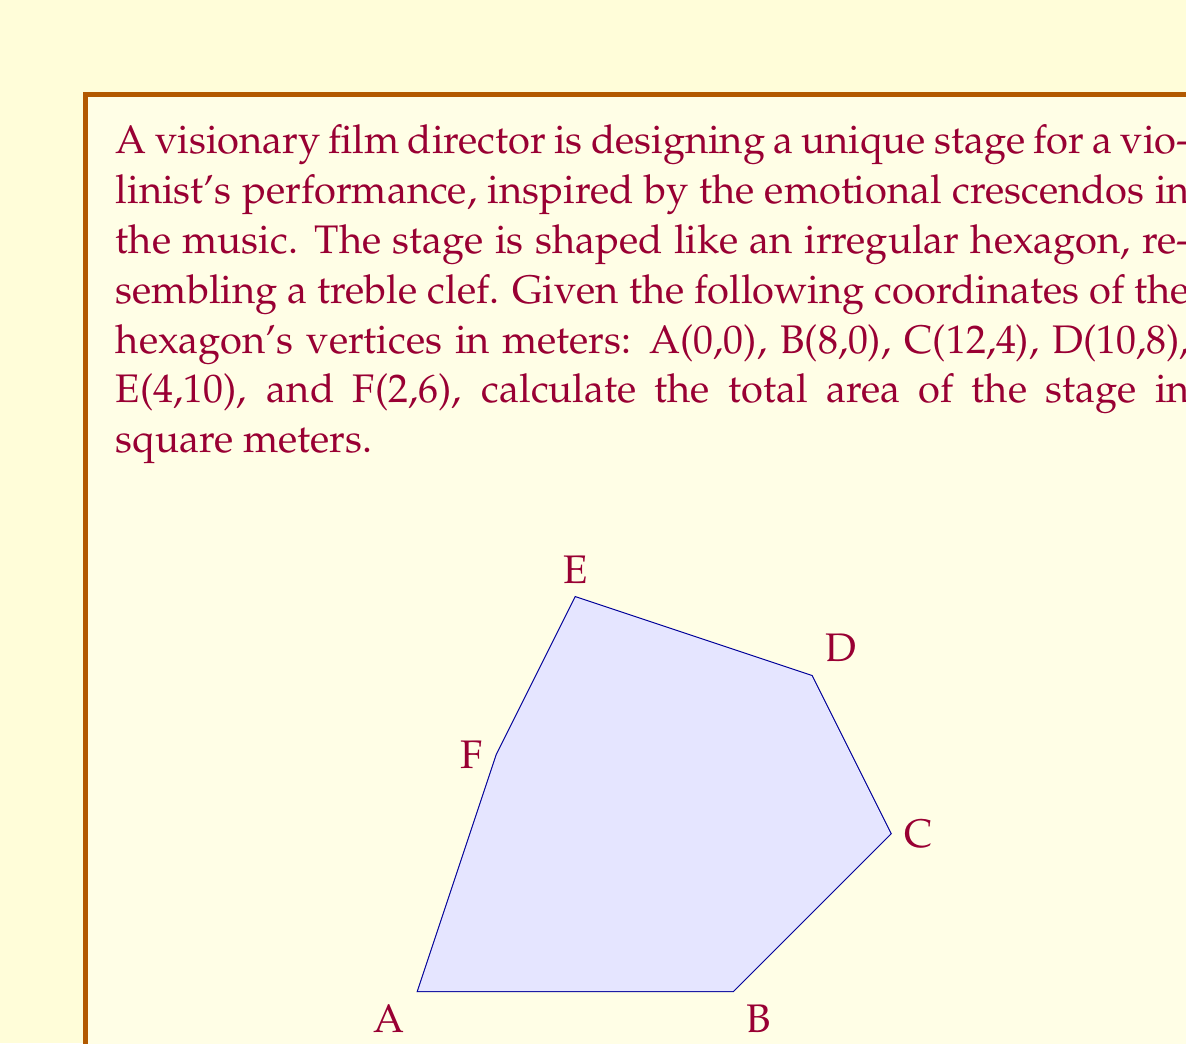Provide a solution to this math problem. To calculate the area of this irregular hexagon, we can use the Shoelace formula (also known as the surveyor's formula). This method works for any polygon given the coordinates of its vertices.

The formula is:

$$ \text{Area} = \frac{1}{2}|(x_1y_2 + x_2y_3 + ... + x_ny_1) - (y_1x_2 + y_2x_3 + ... + y_nx_1)| $$

Where $(x_i, y_i)$ are the coordinates of the $i$-th vertex.

Let's apply this formula to our hexagon:

1) First, let's arrange the vertices in order:
   A(0,0), B(8,0), C(12,4), D(10,8), E(4,10), F(2,6)

2) Now, let's calculate the first part of the formula:
   $x_1y_2 + x_2y_3 + x_3y_4 + x_4y_5 + x_5y_6 + x_6y_1$
   $= (0 \cdot 0) + (8 \cdot 4) + (12 \cdot 8) + (10 \cdot 10) + (4 \cdot 6) + (2 \cdot 0)$
   $= 0 + 32 + 96 + 100 + 24 + 0 = 252$

3) Next, let's calculate the second part:
   $y_1x_2 + y_2x_3 + y_3x_4 + y_4x_5 + y_5x_6 + y_6x_1$
   $= (0 \cdot 8) + (0 \cdot 12) + (4 \cdot 10) + (8 \cdot 4) + (10 \cdot 2) + (6 \cdot 0)$
   $= 0 + 0 + 40 + 32 + 20 + 0 = 92$

4) Now, we subtract the second part from the first and take the absolute value:
   $|252 - 92| = 160$

5) Finally, we divide by 2:
   $\frac{160}{2} = 80$

Therefore, the area of the stage is 80 square meters.
Answer: 80 m² 